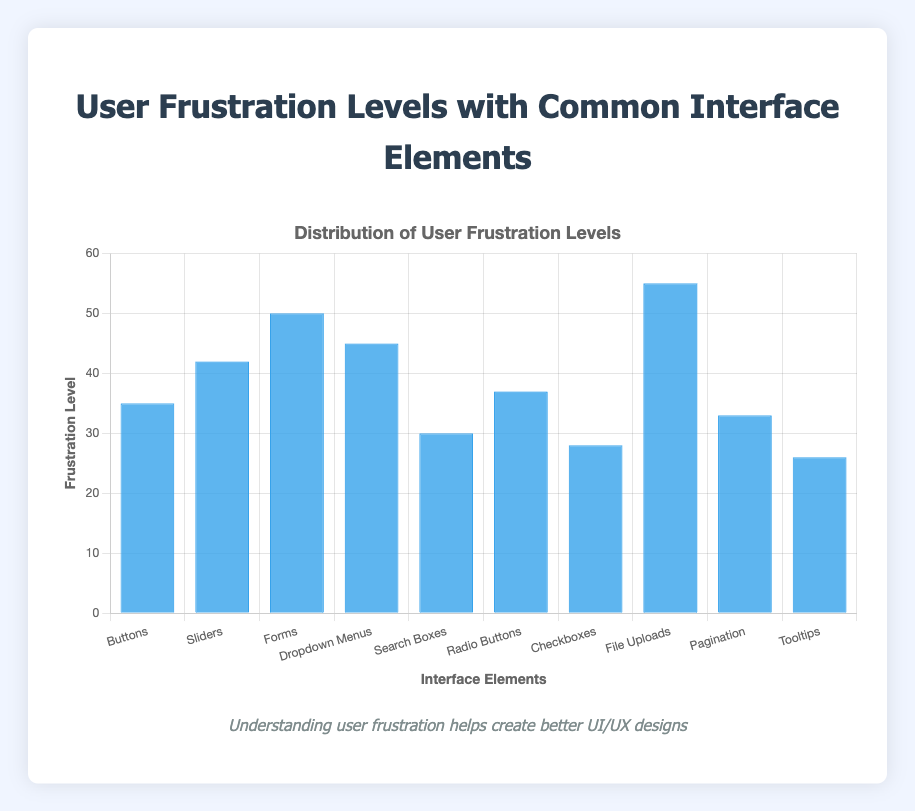Which interface element has the highest user frustration level? The highest bar represents the interface element with the highest user frustration level. The "File Uploads" bar is the tallest at 55.
Answer: File Uploads Which interface element has the lowest user frustration level? The shortest bar represents the interface element with the lowest user frustration level. The "Tooltips" bar is the shortest at 26.
Answer: Tooltips How does the user frustration level for "Forms" compare to that for "Buttons"? The height of the bars for "Forms" and "Buttons" are compared. "Forms" has a frustration level of 50, while "Buttons" has a level of 35. So, "Forms" has a higher frustration level by 15.
Answer: Forms is 15 higher What is the frustration level difference between "Dropdown Menus" and "Checkboxes"? The frustration levels for "Dropdown Menus" (45) and "Checkboxes" (28) are subtracted to find the difference: 45 - 28.
Answer: 17 Which interface element has the frustration level closest to 40? By visually inspecting the bars, the frustration levels closest to 40 are examined. The "Sliders" bar, which is 42, is the closest.
Answer: Sliders What is the average frustration level of all the interface elements? All frustration levels are summed: 35 + 42 + 50 + 45 + 30 + 37 + 28 + 55 + 33 + 26 = 381. Then, this is divided by the number of elements: 381 / 10.
Answer: 38.1 What is the combined user frustration level of "Pagination" and "Search Boxes"? Frustration levels for "Pagination" (33) and "Search Boxes" (30) are summed: 33 + 30.
Answer: 63 Is the user frustration level for "Radio Buttons" more than "Buttons"? The heights of the bars for "Radio Buttons" and "Buttons" are compared. "Radio Buttons" has a level of 37, and "Buttons" has 35.
Answer: Yes How much higher is the frustration level for "File Uploads" compared to "Search Boxes"? The frustration levels for "File Uploads" (55) and "Search Boxes" (30) are compared: 55 - 30.
Answer: 25 Which interface elements have a frustration level above 40? Bars higher than the 40-mark are identified: "Sliders" (42), "Forms" (50), "Dropdown Menus" (45), and "File Uploads" (55).
Answer: Sliders, Forms, Dropdown Menus, File Uploads 